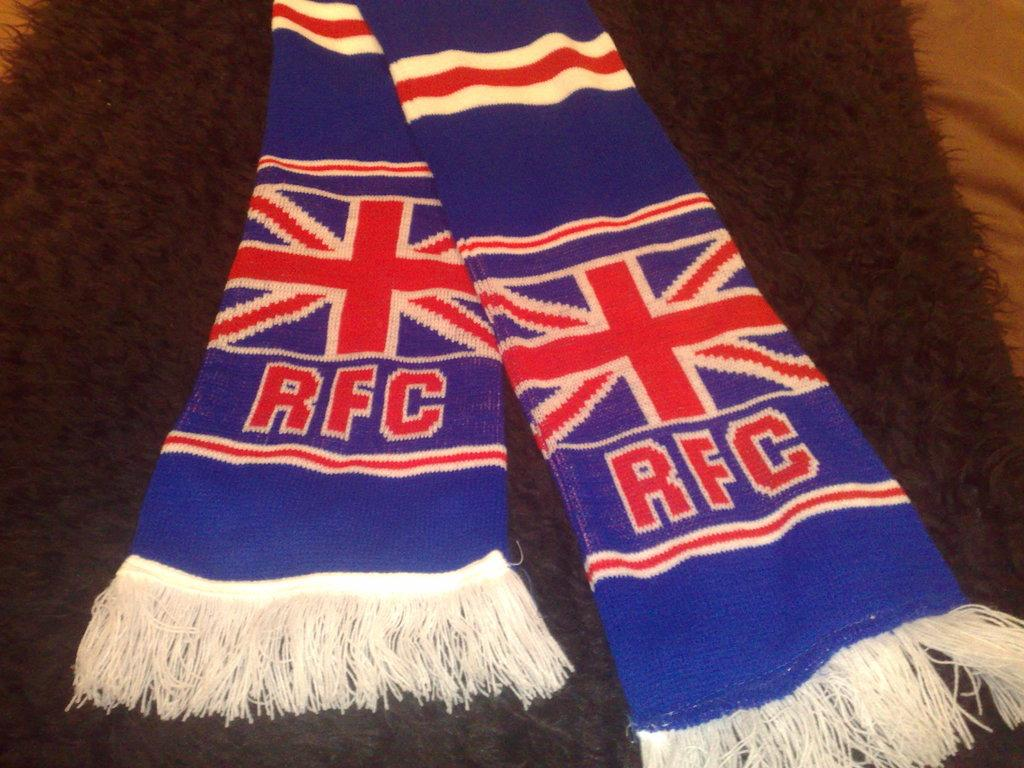<image>
Give a short and clear explanation of the subsequent image. Blue scarf with red and white and red RFC letters on the bottom of each scarf tail. 